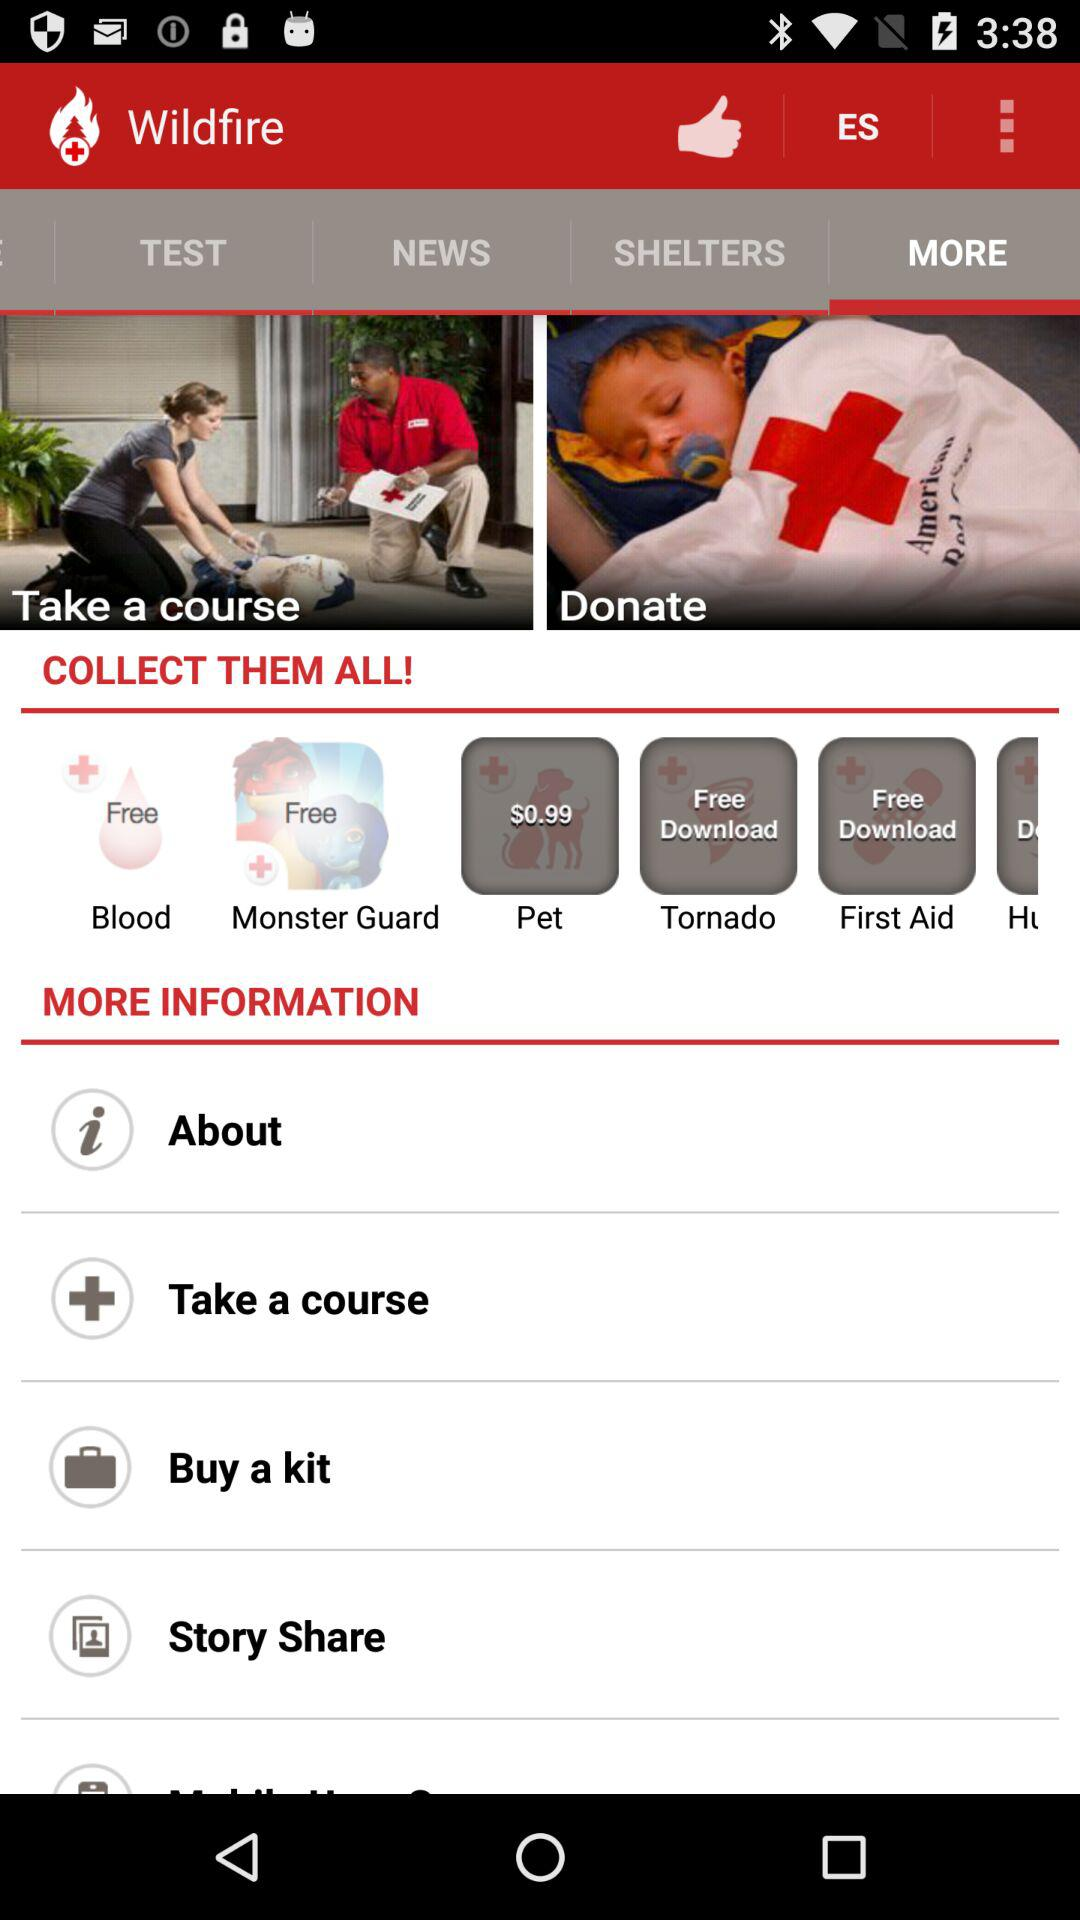Which tab is selected? The selected tab is more. 